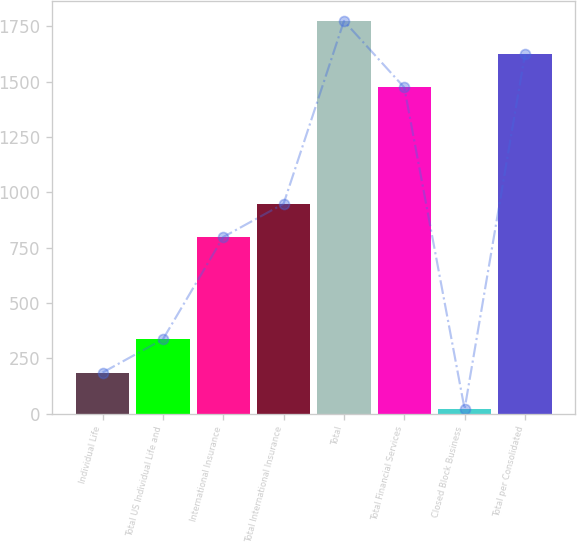Convert chart to OTSL. <chart><loc_0><loc_0><loc_500><loc_500><bar_chart><fcel>Individual Life<fcel>Total US Individual Life and<fcel>International Insurance<fcel>Total International Insurance<fcel>Total<fcel>Total Financial Services<fcel>Closed Block Business<fcel>Total per Consolidated<nl><fcel>186<fcel>336.1<fcel>798<fcel>948.1<fcel>1773.2<fcel>1473<fcel>21<fcel>1623.1<nl></chart> 